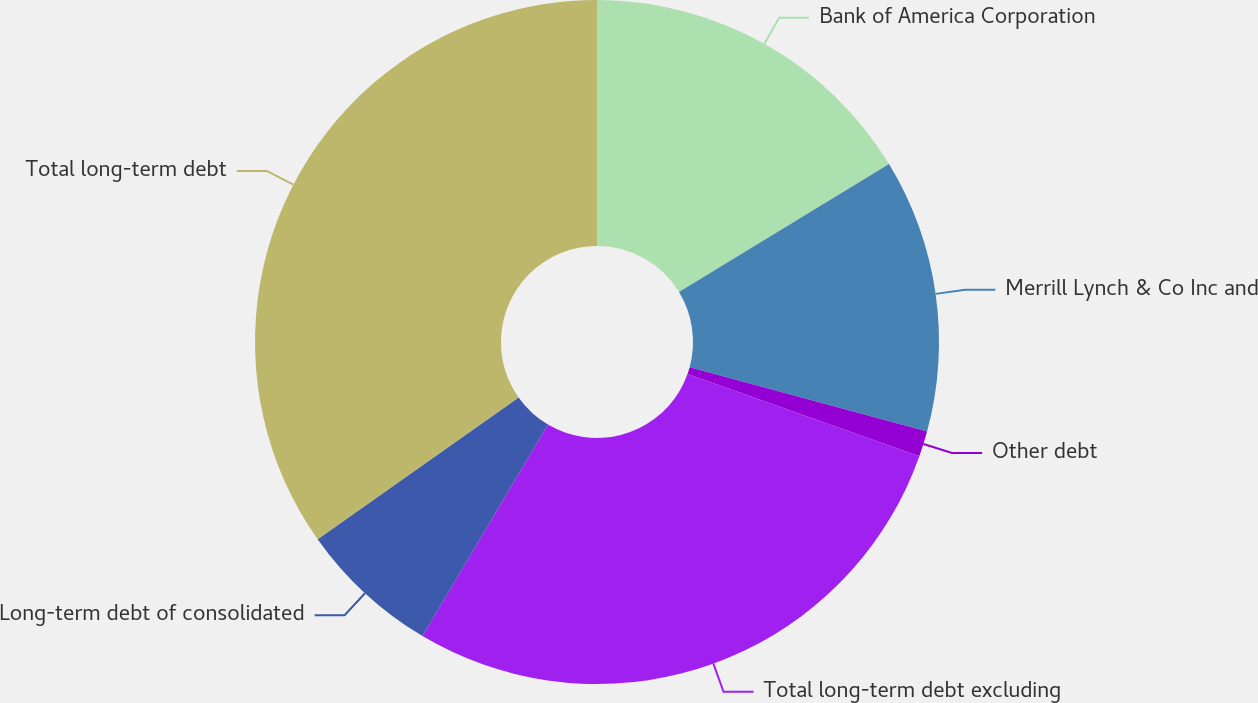Convert chart to OTSL. <chart><loc_0><loc_0><loc_500><loc_500><pie_chart><fcel>Bank of America Corporation<fcel>Merrill Lynch & Co Inc and<fcel>Other debt<fcel>Total long-term debt excluding<fcel>Long-term debt of consolidated<fcel>Total long-term debt<nl><fcel>16.29%<fcel>12.93%<fcel>1.21%<fcel>28.1%<fcel>6.69%<fcel>34.79%<nl></chart> 